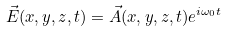<formula> <loc_0><loc_0><loc_500><loc_500>\vec { E } ( x , y , z , t ) = \vec { A } ( x , y , z , t ) e ^ { i \omega _ { 0 } t }</formula> 